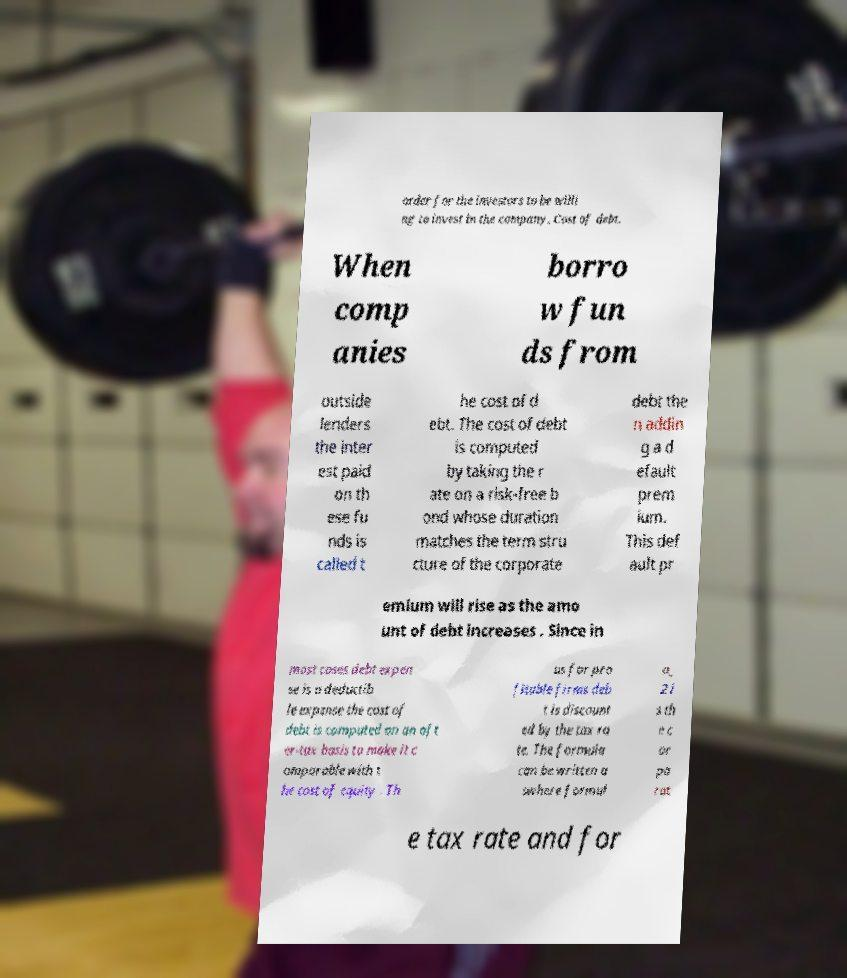Can you read and provide the text displayed in the image?This photo seems to have some interesting text. Can you extract and type it out for me? order for the investors to be willi ng to invest in the company. Cost of debt. When comp anies borro w fun ds from outside lenders the inter est paid on th ese fu nds is called t he cost of d ebt. The cost of debt is computed by taking the r ate on a risk-free b ond whose duration matches the term stru cture of the corporate debt the n addin g a d efault prem ium. This def ault pr emium will rise as the amo unt of debt increases . Since in most cases debt expen se is a deductib le expense the cost of debt is computed on an aft er-tax basis to make it c omparable with t he cost of equity . Th us for pro fitable firms deb t is discount ed by the tax ra te. The formula can be written a swhere formul a_ 2 i s th e c or po rat e tax rate and for 